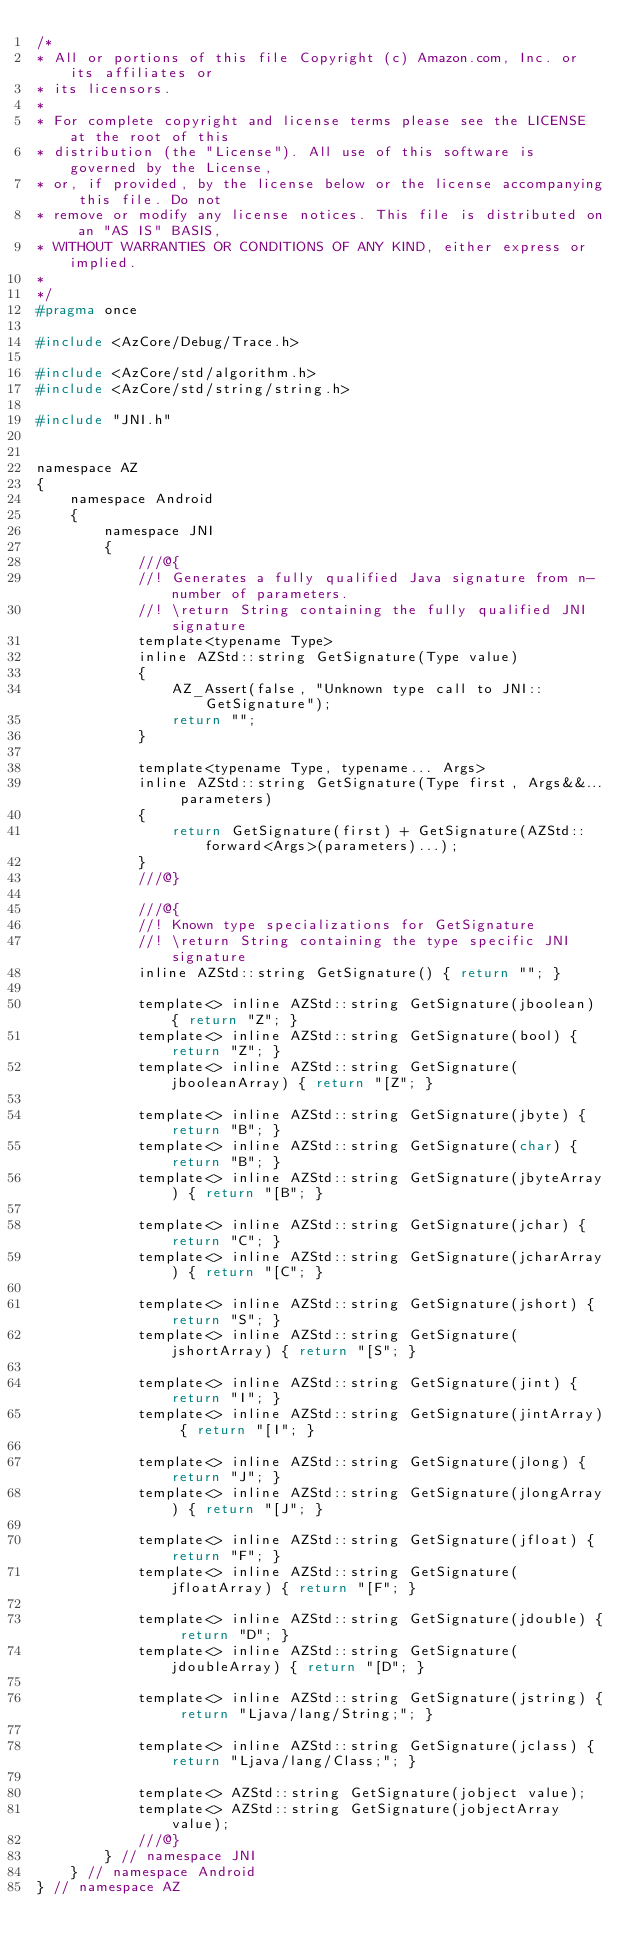Convert code to text. <code><loc_0><loc_0><loc_500><loc_500><_C_>/*
* All or portions of this file Copyright (c) Amazon.com, Inc. or its affiliates or
* its licensors.
*
* For complete copyright and license terms please see the LICENSE at the root of this
* distribution (the "License"). All use of this software is governed by the License,
* or, if provided, by the license below or the license accompanying this file. Do not
* remove or modify any license notices. This file is distributed on an "AS IS" BASIS,
* WITHOUT WARRANTIES OR CONDITIONS OF ANY KIND, either express or implied.
*
*/
#pragma once

#include <AzCore/Debug/Trace.h>

#include <AzCore/std/algorithm.h>
#include <AzCore/std/string/string.h>

#include "JNI.h"


namespace AZ
{
    namespace Android
    {
        namespace JNI
        {
            ///@{
            //! Generates a fully qualified Java signature from n-number of parameters.
            //! \return String containing the fully qualified JNI signature
            template<typename Type>
            inline AZStd::string GetSignature(Type value)
            {
                AZ_Assert(false, "Unknown type call to JNI::GetSignature");
                return "";
            }

            template<typename Type, typename... Args>
            inline AZStd::string GetSignature(Type first, Args&&... parameters)
            {
                return GetSignature(first) + GetSignature(AZStd::forward<Args>(parameters)...);
            }
            ///@}

            ///@{
            //! Known type specializations for GetSignature
            //! \return String containing the type specific JNI signature
            inline AZStd::string GetSignature() { return ""; }

            template<> inline AZStd::string GetSignature(jboolean) { return "Z"; }
            template<> inline AZStd::string GetSignature(bool) { return "Z"; }
            template<> inline AZStd::string GetSignature(jbooleanArray) { return "[Z"; }

            template<> inline AZStd::string GetSignature(jbyte) { return "B"; }
            template<> inline AZStd::string GetSignature(char) { return "B"; }
            template<> inline AZStd::string GetSignature(jbyteArray) { return "[B"; }

            template<> inline AZStd::string GetSignature(jchar) { return "C"; }
            template<> inline AZStd::string GetSignature(jcharArray) { return "[C"; }

            template<> inline AZStd::string GetSignature(jshort) { return "S"; }
            template<> inline AZStd::string GetSignature(jshortArray) { return "[S"; }

            template<> inline AZStd::string GetSignature(jint) { return "I"; }
            template<> inline AZStd::string GetSignature(jintArray) { return "[I"; }

            template<> inline AZStd::string GetSignature(jlong) { return "J"; }
            template<> inline AZStd::string GetSignature(jlongArray) { return "[J"; }

            template<> inline AZStd::string GetSignature(jfloat) { return "F"; }
            template<> inline AZStd::string GetSignature(jfloatArray) { return "[F"; }

            template<> inline AZStd::string GetSignature(jdouble) { return "D"; }
            template<> inline AZStd::string GetSignature(jdoubleArray) { return "[D"; }

            template<> inline AZStd::string GetSignature(jstring) { return "Ljava/lang/String;"; }

            template<> inline AZStd::string GetSignature(jclass) { return "Ljava/lang/Class;"; }

            template<> AZStd::string GetSignature(jobject value);
            template<> AZStd::string GetSignature(jobjectArray value);
            ///@}
        } // namespace JNI
    } // namespace Android
} // namespace AZ

</code> 